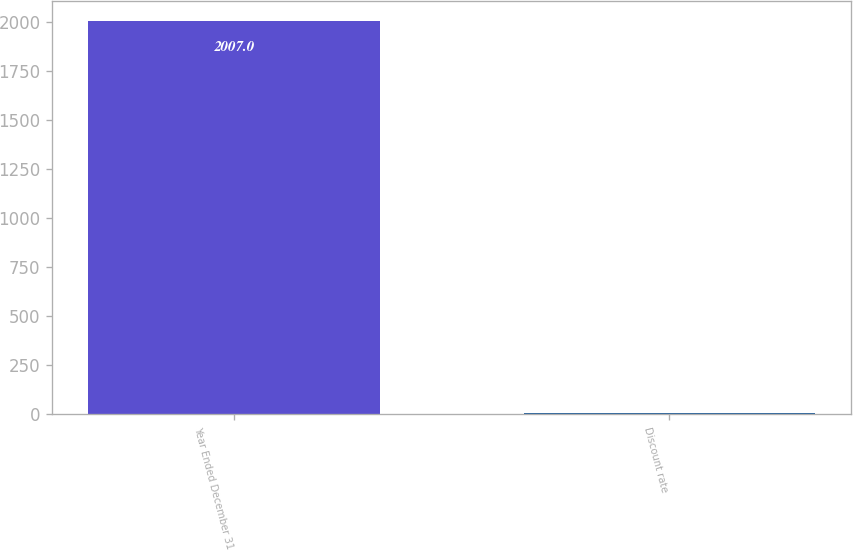<chart> <loc_0><loc_0><loc_500><loc_500><bar_chart><fcel>Year Ended December 31<fcel>Discount rate<nl><fcel>2007<fcel>5.7<nl></chart> 